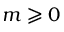Convert formula to latex. <formula><loc_0><loc_0><loc_500><loc_500>m \geqslant 0</formula> 